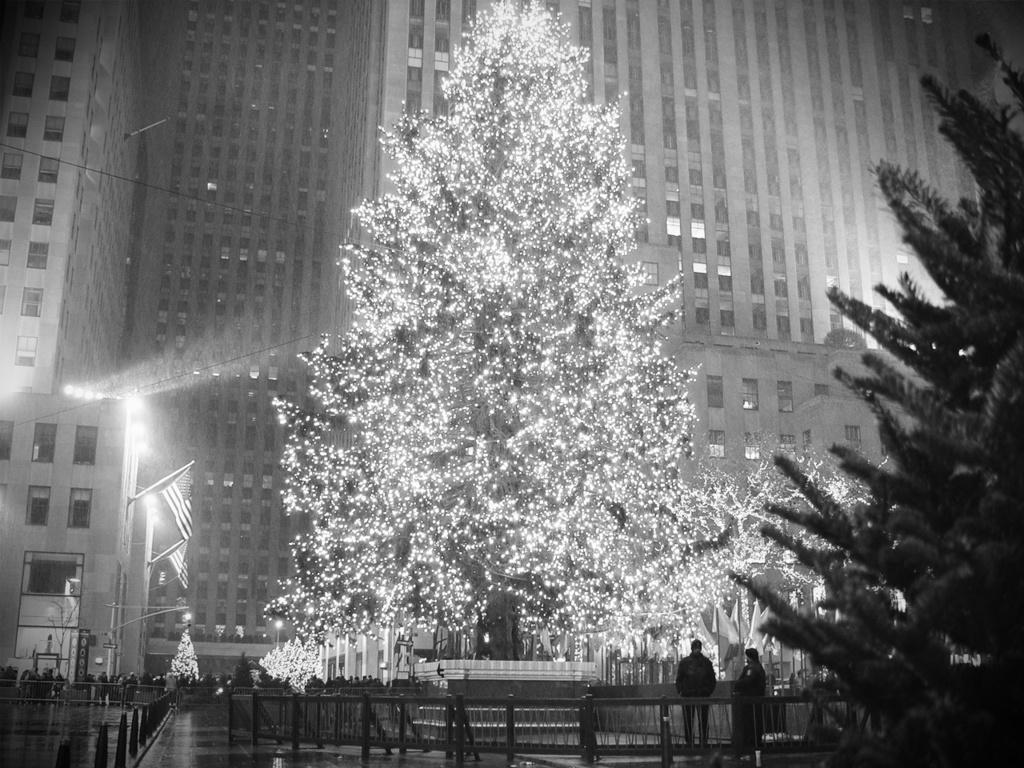How would you summarize this image in a sentence or two? It is a black and white picture. In this image there are three, flags, light poles, railings, people, boards, buildings, decorative lights and objects.  